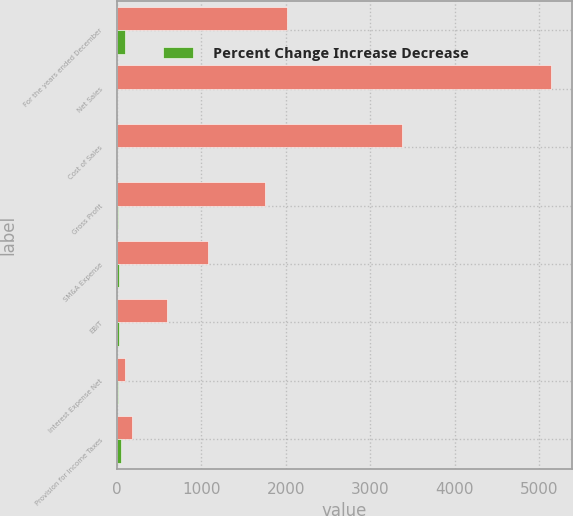Convert chart. <chart><loc_0><loc_0><loc_500><loc_500><stacked_bar_chart><ecel><fcel>For the years ended December<fcel>Net Sales<fcel>Cost of Sales<fcel>Gross Profit<fcel>SM&A Expense<fcel>EBIT<fcel>Interest Expense Net<fcel>Provision for Income Taxes<nl><fcel>nan<fcel>2008<fcel>5132.8<fcel>3375.1<fcel>1757.7<fcel>1073<fcel>589.9<fcel>97.9<fcel>180.6<nl><fcel>Percent Change Increase Decrease<fcel>97.9<fcel>3.8<fcel>1.8<fcel>7.7<fcel>19.8<fcel>28.6<fcel>17.5<fcel>43.2<nl></chart> 